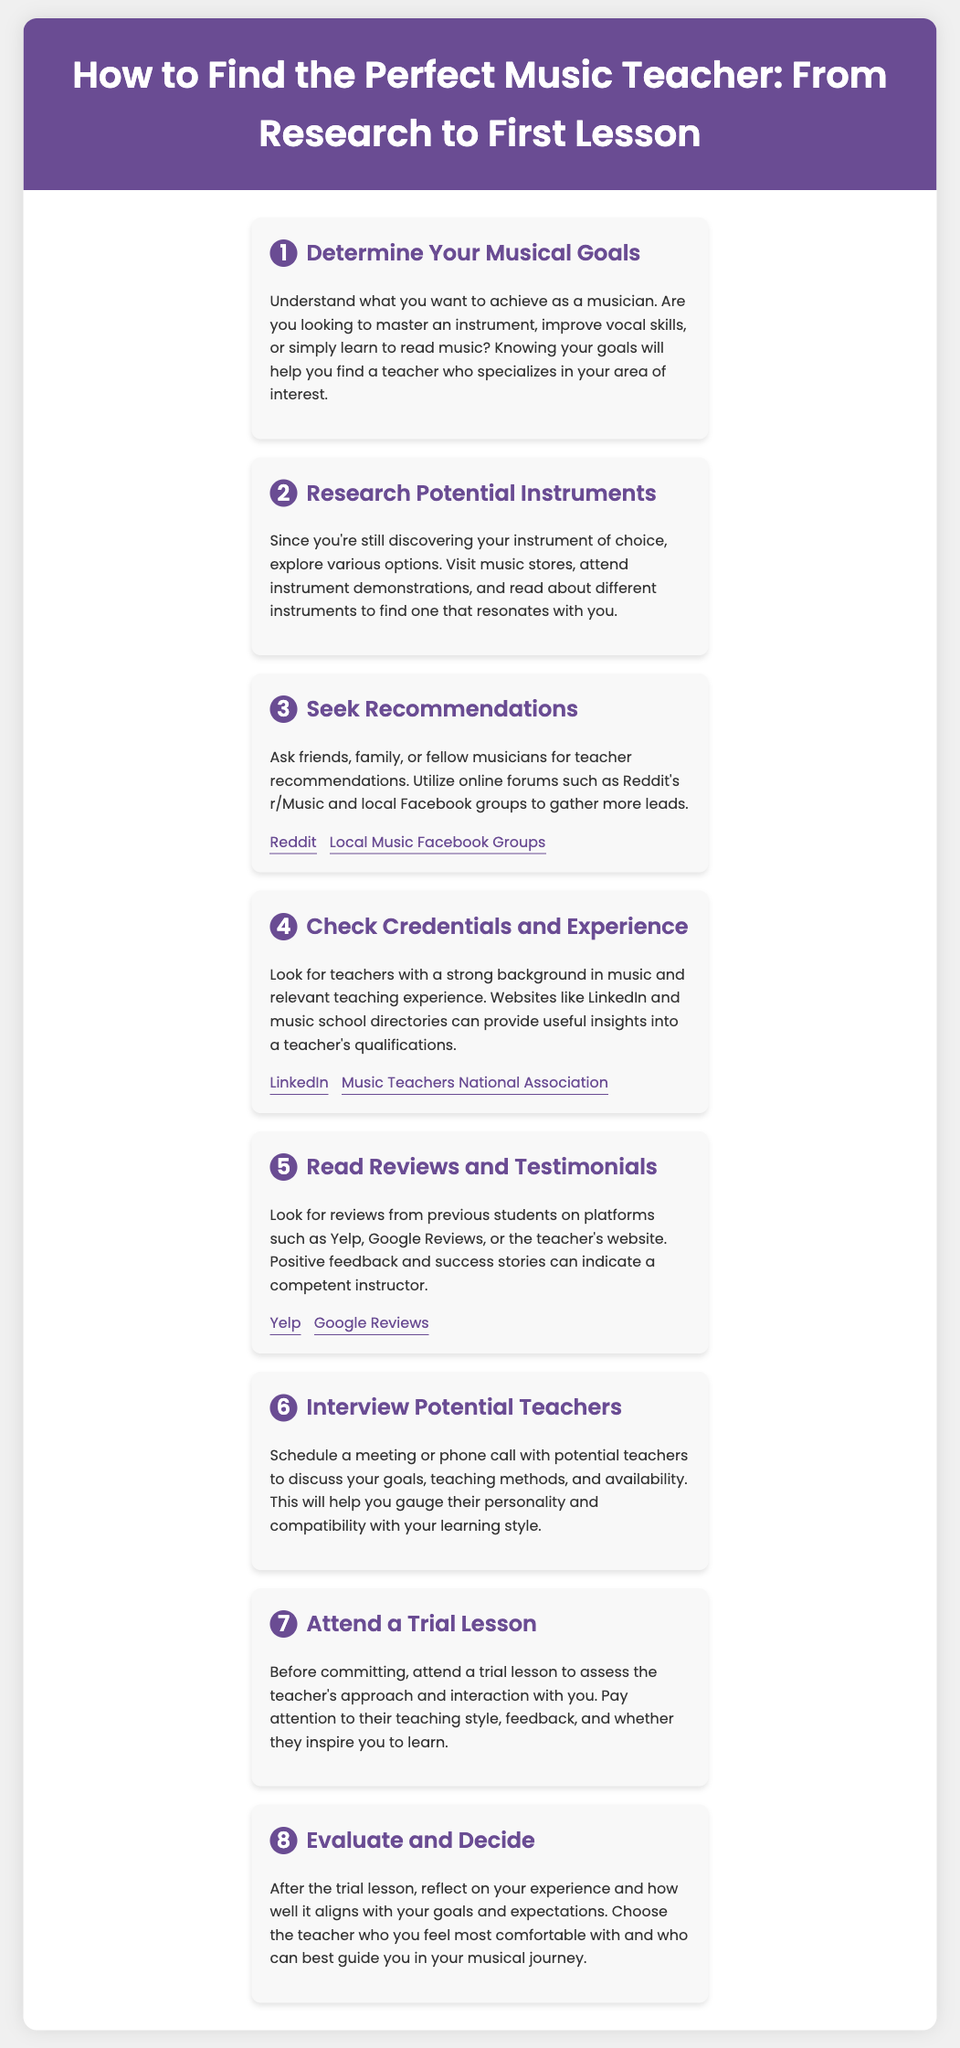What is the first step to finding a music teacher? The first step is to determine your musical goals, which will guide you in your search for a specialized teacher.
Answer: Determine Your Musical Goals What should you explore in step 2? In step 2, you need to research potential instruments to find one that resonates with you.
Answer: Research Potential Instruments Which online forum can you use to seek recommendations? You can utilize online forums such as Reddit's r/Music to gather more leads for teacher recommendations.
Answer: Reddit's r/Music What do you check regarding a teacher's qualifications? You should check their credentials and experience in music as part of the evaluation process.
Answer: Credentials and Experience What is a resource to read reviews and testimonials about teachers? You can read reviews and testimonials on platforms such as Yelp and Google Reviews.
Answer: Yelp and Google Reviews How can you assess the teaching style of potential teachers? You can attend a trial lesson, which allows you to evaluate their approach and interaction with you.
Answer: Attend a Trial Lesson What should be your main priority when evaluating after the trial lesson? After the trial lesson, reflect on your experience and how well it aligns with your goals and expectations.
Answer: Aligning with Goals and Expectations Which step involves talking directly with potential teachers? Step 6 involves interviewing potential teachers to discuss your goals and their teaching methods.
Answer: Interview Potential Teachers 